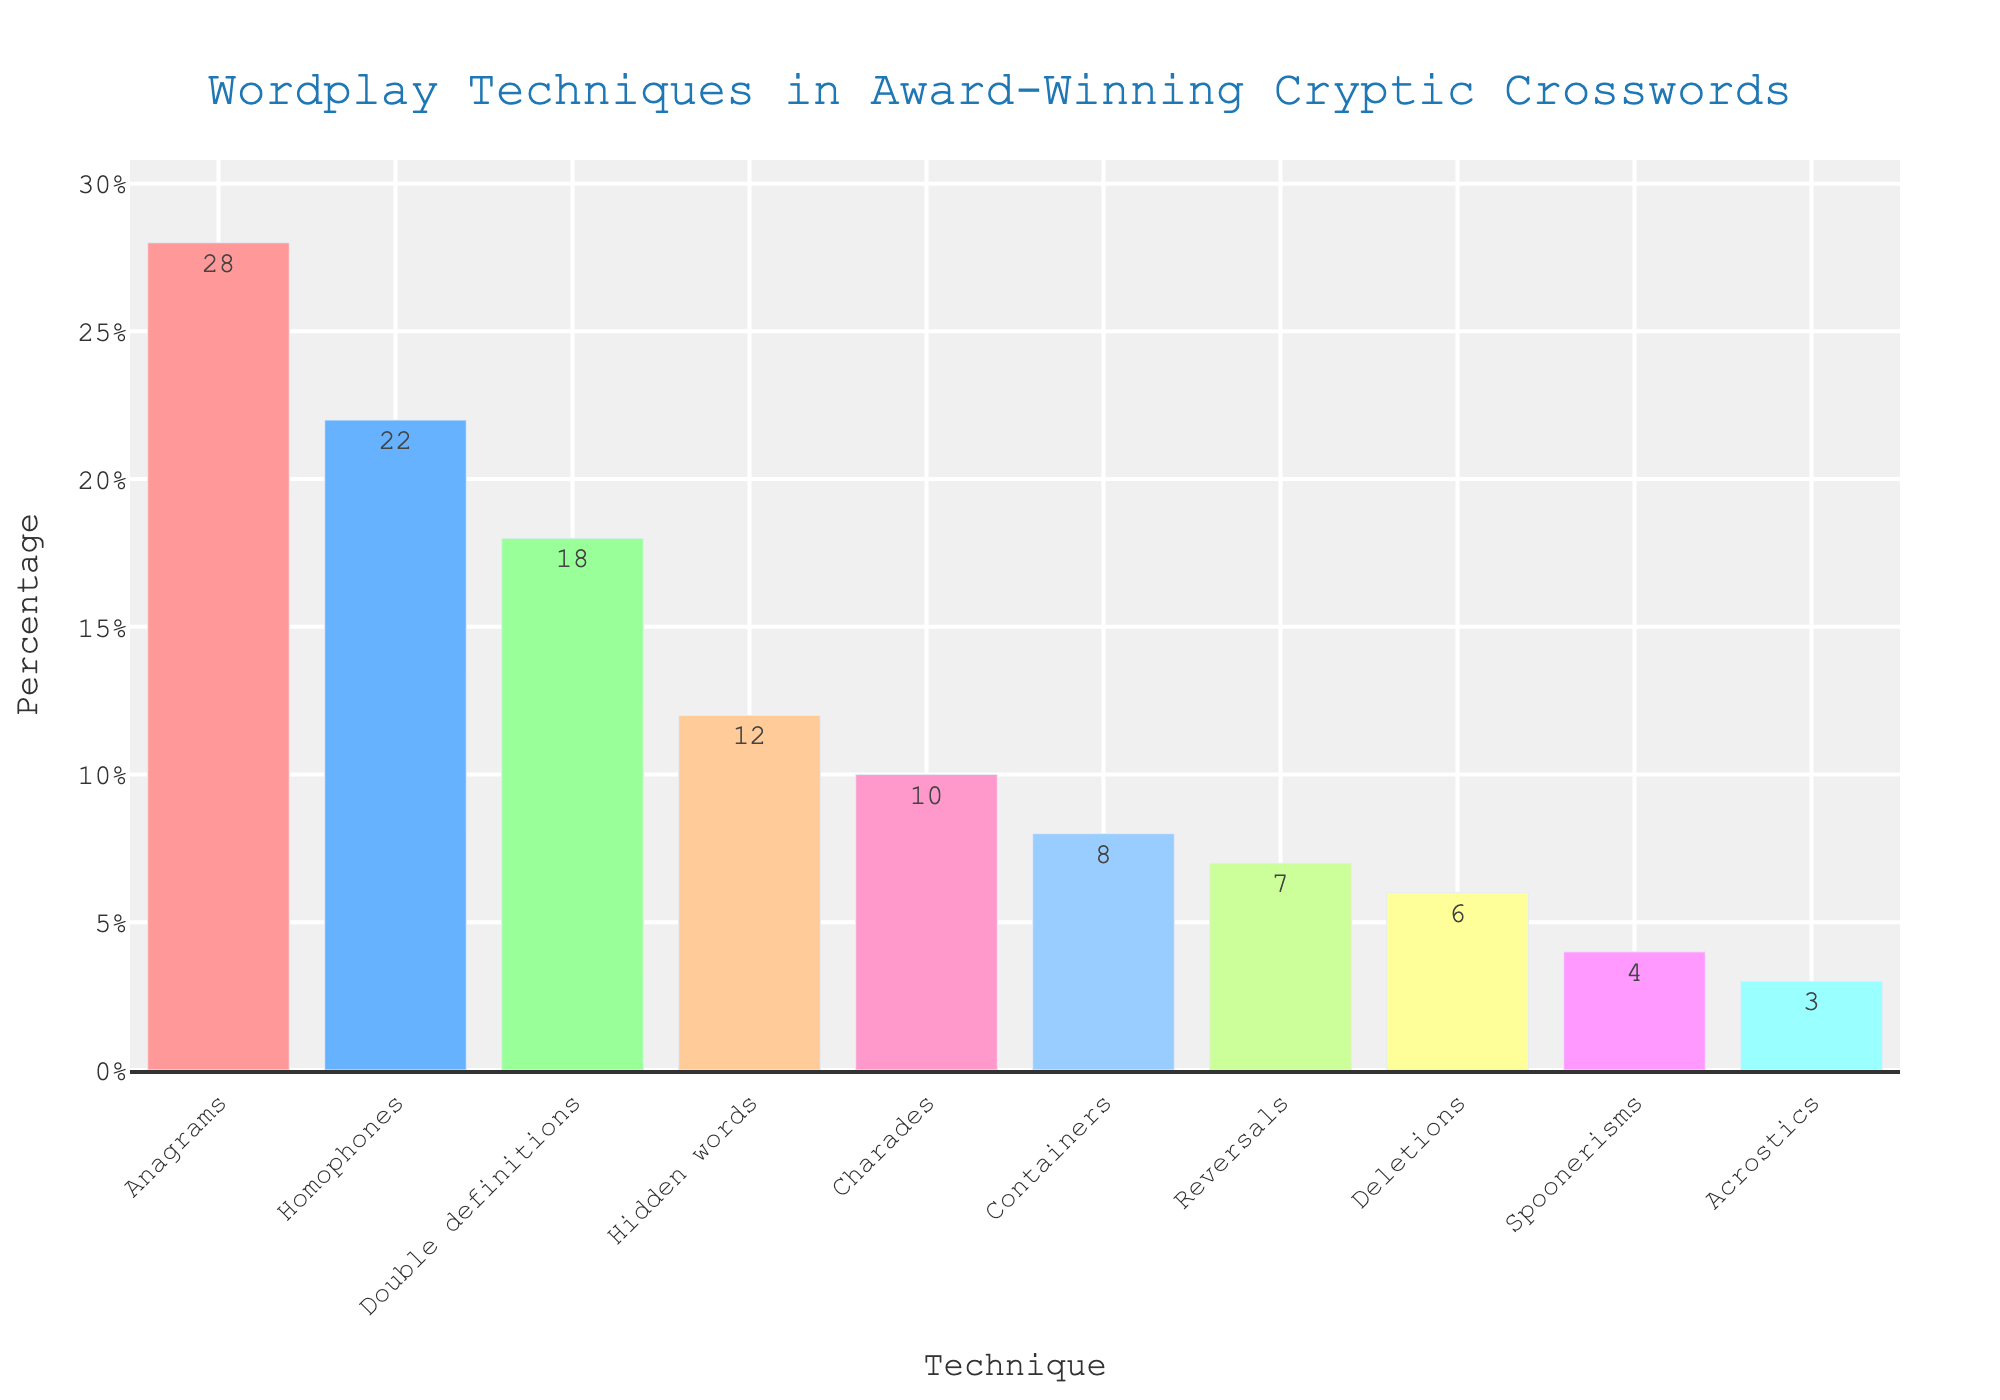Which technique has the highest usage percentage? From the bar chart, the tallest bar represents the technique with the highest usage percentage. This bar corresponds to the label "Anagrams" with 28%.
Answer: Anagrams What is the combined usage percentage of Double definitions and Hidden words? The percentages for Double definitions and Hidden words are 18% and 12% respectively. Adding them up, 18 + 12 = 30.
Answer: 30% Which technique has a lower percentage usage, Charades or Containers? By comparing the heights of the bars labeled Charades (10%) and Containers (8%), we see the bar for Containers is shorter.
Answer: Containers How much higher is the percentage of Anagrams compared to Deletions? The percentage for Anagrams is 28% and for Deletions is 6%. The difference is 28 - 6 = 22.
Answer: 22% List all the techniques with a usage percentage greater than 20%. Techniques with bars extending above the 20% mark are Anagrams (28%) and Homophones (22%).
Answer: Anagrams, Homophones What is the average percentage of Acrostics and Spoonerisms? Percentages of Acrostics and Spoonerisms are 3% and 4% respectively. Their average is (3 + 4) / 2 = 3.5.
Answer: 3.5% What is the total usage percentage of the techniques with a purple bar? The bar for Spoonerisms is purple (4%). The total percentage is thus 4.
Answer: 4% Are there more techniques with a usage percentage above or below 10%? Bars above 10% are 4 (Anagrams, Homophones, Double definitions, Hidden words). Bars below are 6 (Charades, Containers, Reversals, Deletions, Spoonerisms, Acrostics).
Answer: Below What's the difference in usage percentage between the techniques with the highest and the lowest usage? The highest usage percentage is 28% (Anagrams) and the lowest is 3% (Acrostics). The difference is 28 - 3 = 25.
Answer: 25 If you combine the usage of Reversals and Deletions, does it surpass the usage of Double definitions? The percentages for Reversals and Deletions are 7% and 6%, giving a combined sum of 7 + 6 = 13%, which is less than 18% for Double definitions.
Answer: No 